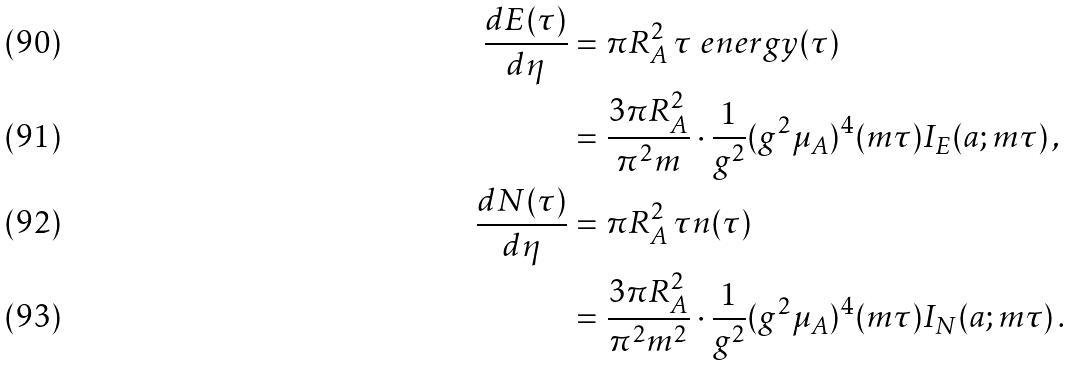Convert formula to latex. <formula><loc_0><loc_0><loc_500><loc_500>\frac { d E ( \tau ) } { d \eta } & = \pi R _ { A } ^ { 2 } \, \tau \ e n e r g y ( \tau ) \\ & = \frac { 3 \pi R _ { A } ^ { 2 } } { \pi ^ { 2 } m } \cdot \frac { 1 } { g ^ { 2 } } ( g ^ { 2 } \mu _ { A } ) ^ { 4 } ( m \tau ) I _ { E } ( a ; m \tau ) \, , \\ \frac { d N ( \tau ) } { d \eta } & = \pi R _ { A } ^ { 2 } \, \tau n ( \tau ) \\ & = \frac { 3 \pi R _ { A } ^ { 2 } } { \pi ^ { 2 } m ^ { 2 } } \cdot \frac { 1 } { g ^ { 2 } } ( g ^ { 2 } \mu _ { A } ) ^ { 4 } ( m \tau ) I _ { N } ( a ; m \tau ) \, .</formula> 